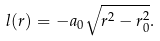Convert formula to latex. <formula><loc_0><loc_0><loc_500><loc_500>l ( r ) = - a _ { 0 } \sqrt { r ^ { 2 } - r _ { 0 } ^ { 2 } } .</formula> 